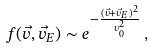Convert formula to latex. <formula><loc_0><loc_0><loc_500><loc_500>f ( \vec { v } , \vec { v } _ { E } ) \sim e ^ { - \frac { ( \vec { v } + \vec { v } _ { E } ) ^ { 2 } } { v _ { 0 } ^ { 2 } } } \, ,</formula> 